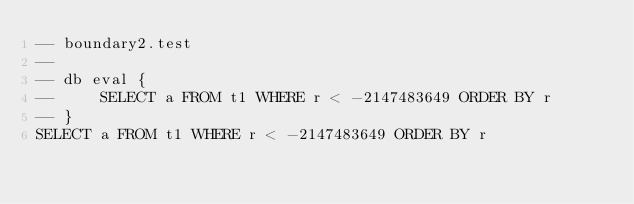Convert code to text. <code><loc_0><loc_0><loc_500><loc_500><_SQL_>-- boundary2.test
-- 
-- db eval {
--     SELECT a FROM t1 WHERE r < -2147483649 ORDER BY r
-- }
SELECT a FROM t1 WHERE r < -2147483649 ORDER BY r</code> 